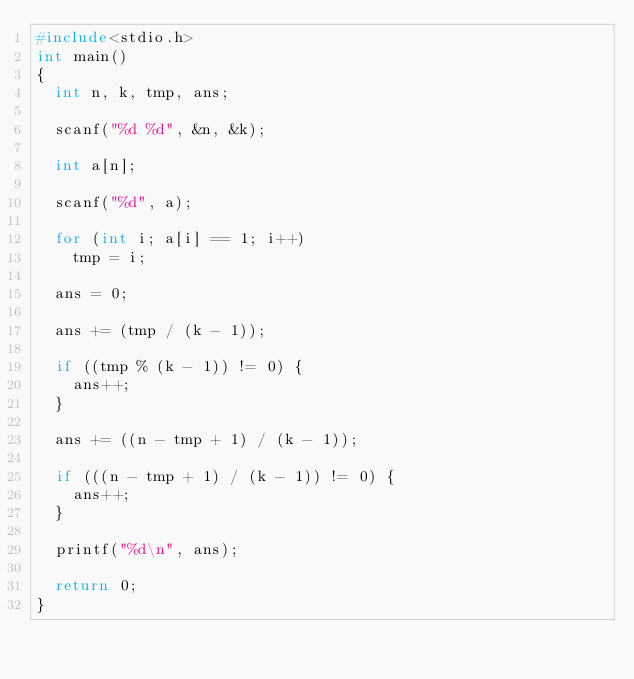Convert code to text. <code><loc_0><loc_0><loc_500><loc_500><_C_>#include<stdio.h>
int main()
{
	int n, k, tmp, ans;

	scanf("%d %d", &n, &k);

	int a[n];

	scanf("%d", a);

	for (int i; a[i] == 1; i++)
		tmp = i;

	ans = 0;

	ans += (tmp / (k - 1));

	if ((tmp % (k - 1)) != 0) {
		ans++;
	}

	ans += ((n - tmp + 1) / (k - 1));

	if (((n - tmp + 1) / (k - 1)) != 0) {
		ans++;
	}

	printf("%d\n", ans);

	return 0;
}</code> 